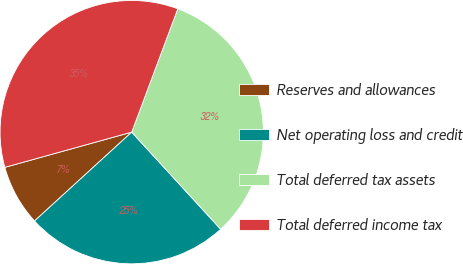Convert chart to OTSL. <chart><loc_0><loc_0><loc_500><loc_500><pie_chart><fcel>Reserves and allowances<fcel>Net operating loss and credit<fcel>Total deferred tax assets<fcel>Total deferred income tax<nl><fcel>7.48%<fcel>25.02%<fcel>32.5%<fcel>35.0%<nl></chart> 